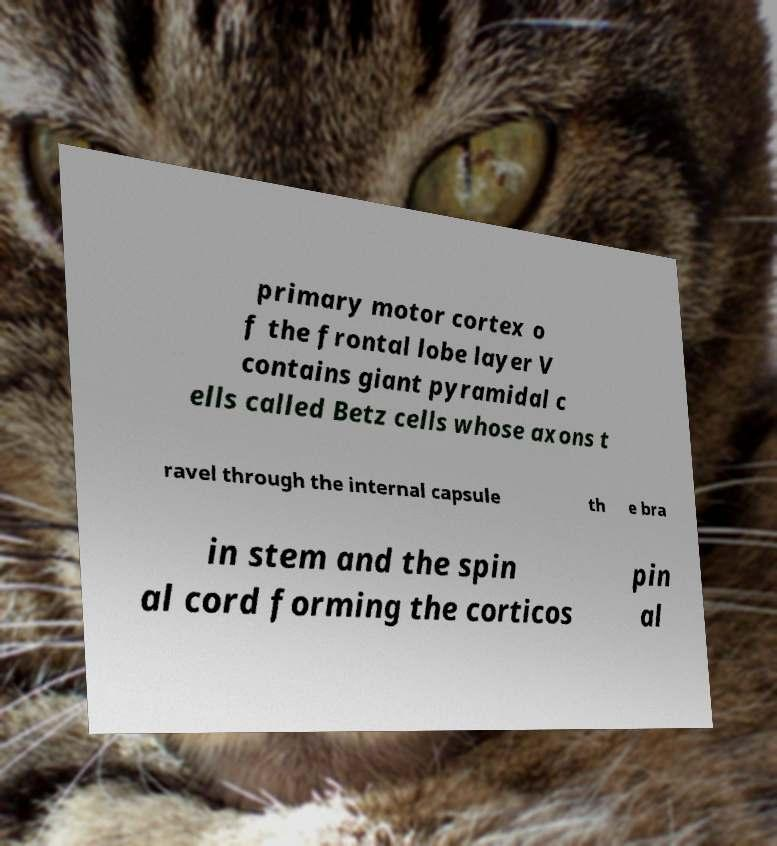What messages or text are displayed in this image? I need them in a readable, typed format. primary motor cortex o f the frontal lobe layer V contains giant pyramidal c ells called Betz cells whose axons t ravel through the internal capsule th e bra in stem and the spin al cord forming the corticos pin al 